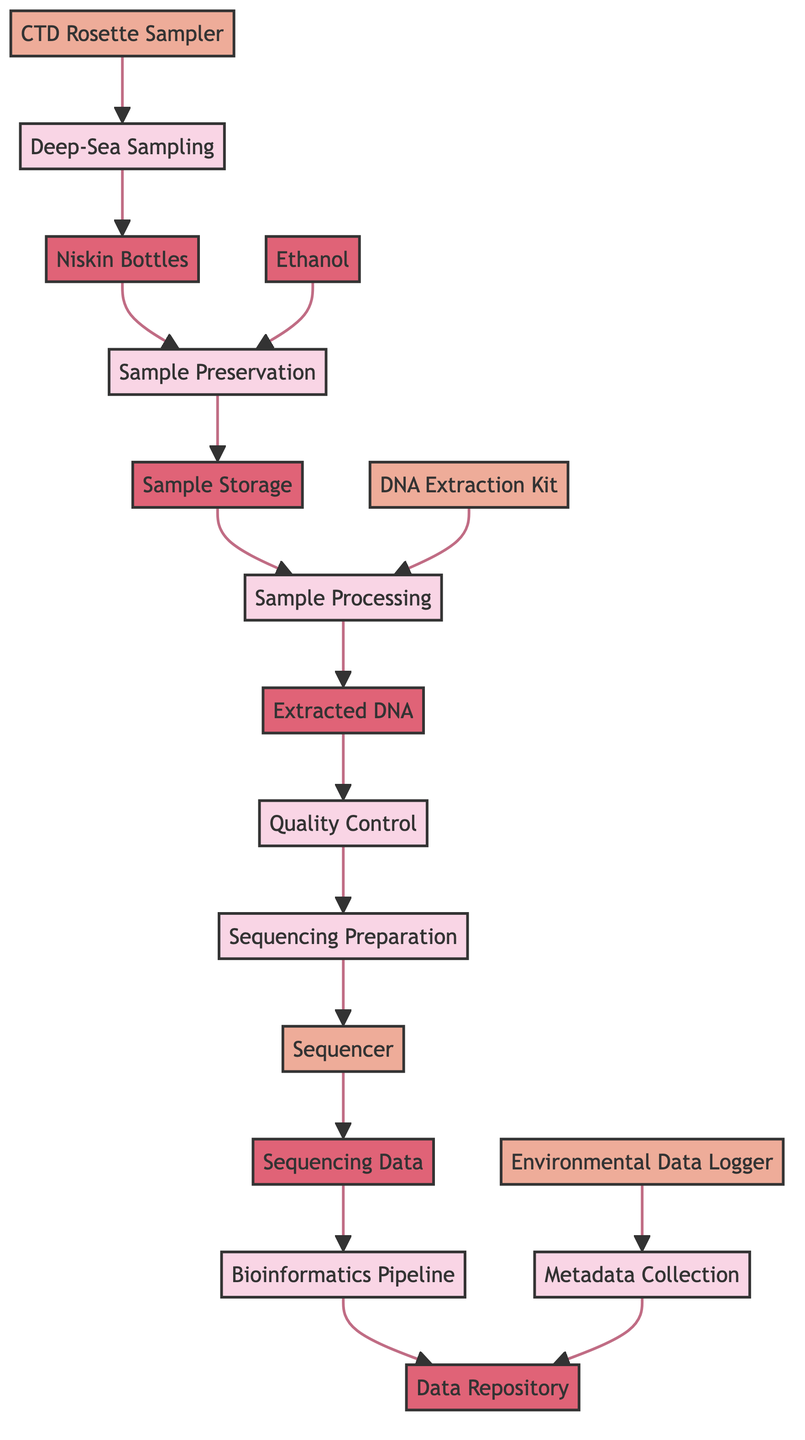What is the first process in the data flow diagram? The first process in the diagram is labeled as "Deep-Sea Sampling," which represents the initial step of collecting microbial samples.
Answer: Deep-Sea Sampling How many external entities are present in the diagram? The diagram includes four external entities: CTD Rosette Sampler, DNA Extraction Kit, Sequencer, and Environmental Data Logger. Count these entities as depicted in the visual.
Answer: 4 What is the final data store in the workflow? The final data store is identified as "Data Repository," where processed data and metadata are stored for further applications.
Answer: Data Repository Which process follows Sample Storage? The process that follows Sample Storage is "Sample Processing," indicating the next step where the stored samples are prepared for sequencing.
Answer: Sample Processing What type of data store is Extracted DNA? Extracted DNA is categorized as a "data_store," representing the storage of purified DNA after extraction and before further analysis.
Answer: data_store What type of process is Quality Control? Quality Control is classified as a "process," and it involves the verification of DNA integrity and purity through specific techniques.
Answer: process Which external entity provides environmental parameters for Metadata Collection? The Environmental Data Logger is the external entity that captures environmental parameters, which are then collected as metadata for further analysis.
Answer: Environmental Data Logger What is the purpose of the Sequencer in this workflow? The Sequencer is used for high-throughput sequencing of DNA libraries, enabling the analysis of extracted microbial genetic material.
Answer: high-throughput sequencing How does Sample Preservation interact with Ethanol? Sample Preservation involves the application of Ethanol as a preservative to maintain sample integrity during transport, directly linked in the flow.
Answer: Ethanol 